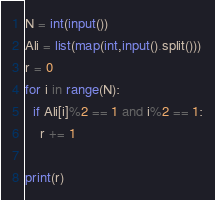Convert code to text. <code><loc_0><loc_0><loc_500><loc_500><_Python_>N = int(input())
Ali = list(map(int,input().split()))
r = 0
for i in range(N):
  if Ali[i]%2 == 1 and i%2 == 1:
    r += 1
    
print(r)</code> 